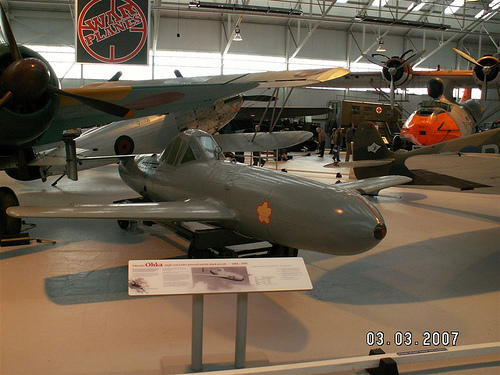<image>
Is the aircraft above the poster? No. The aircraft is not positioned above the poster. The vertical arrangement shows a different relationship. 